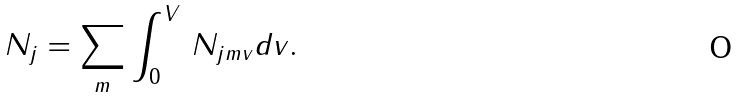<formula> <loc_0><loc_0><loc_500><loc_500>N _ { j } = \sum _ { m } \int _ { 0 } ^ { V } \, N _ { j m v } d v .</formula> 